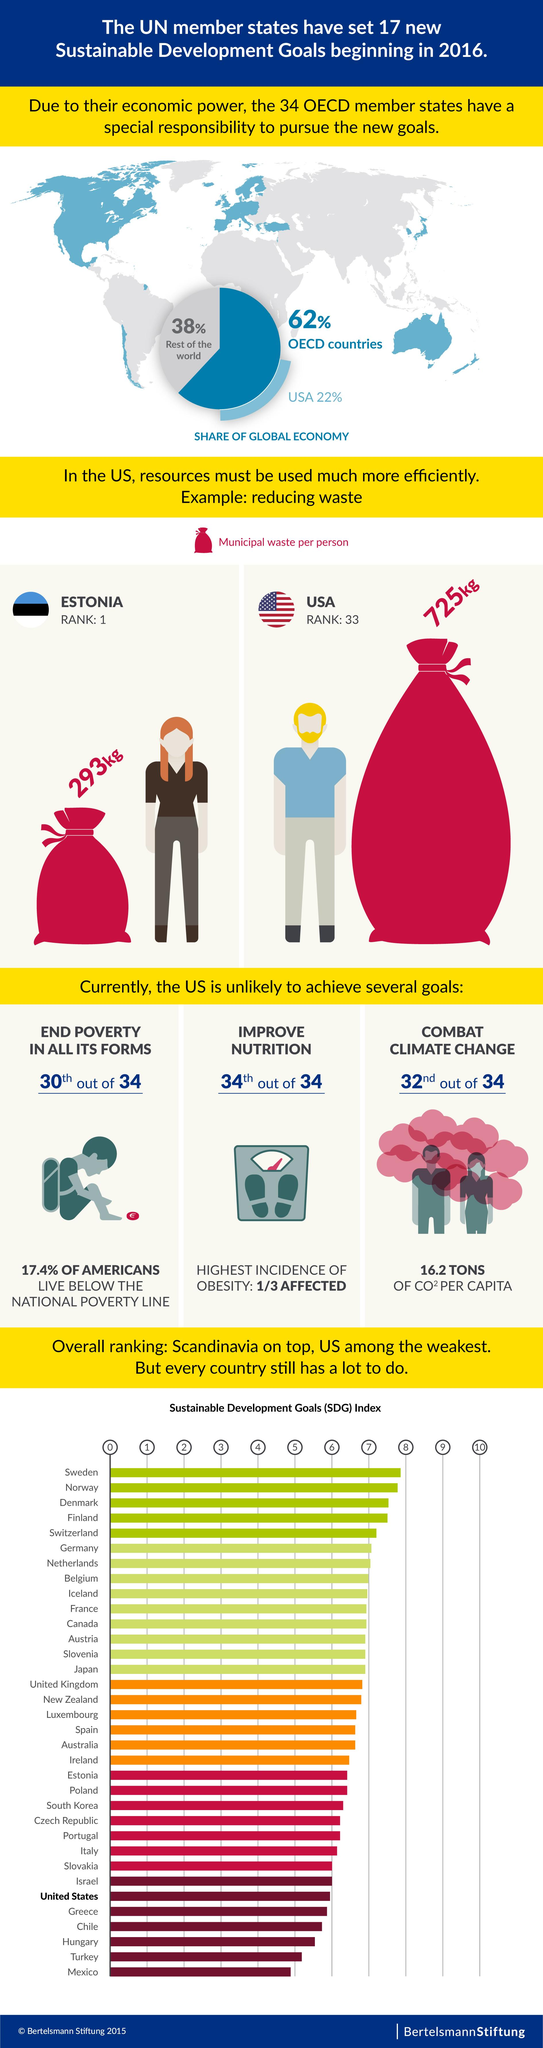Identify some key points in this picture. On average, every person in the United States generates approximately 725 kilograms of municipal waste per year. According to recent data, a staggering 82.6% of Americans live above the national poverty line. This is a concerning statistic that highlights the need for policies and initiatives aimed at addressing poverty and improving the economic well-being of all Americans. The share of the global economy held by OECD countries is 62%. The United States holds a 22% share of the global economy, making it a significant player in the global economic landscape. On average, each person in Estonia generates approximately 293 kilograms of municipal waste per year. 